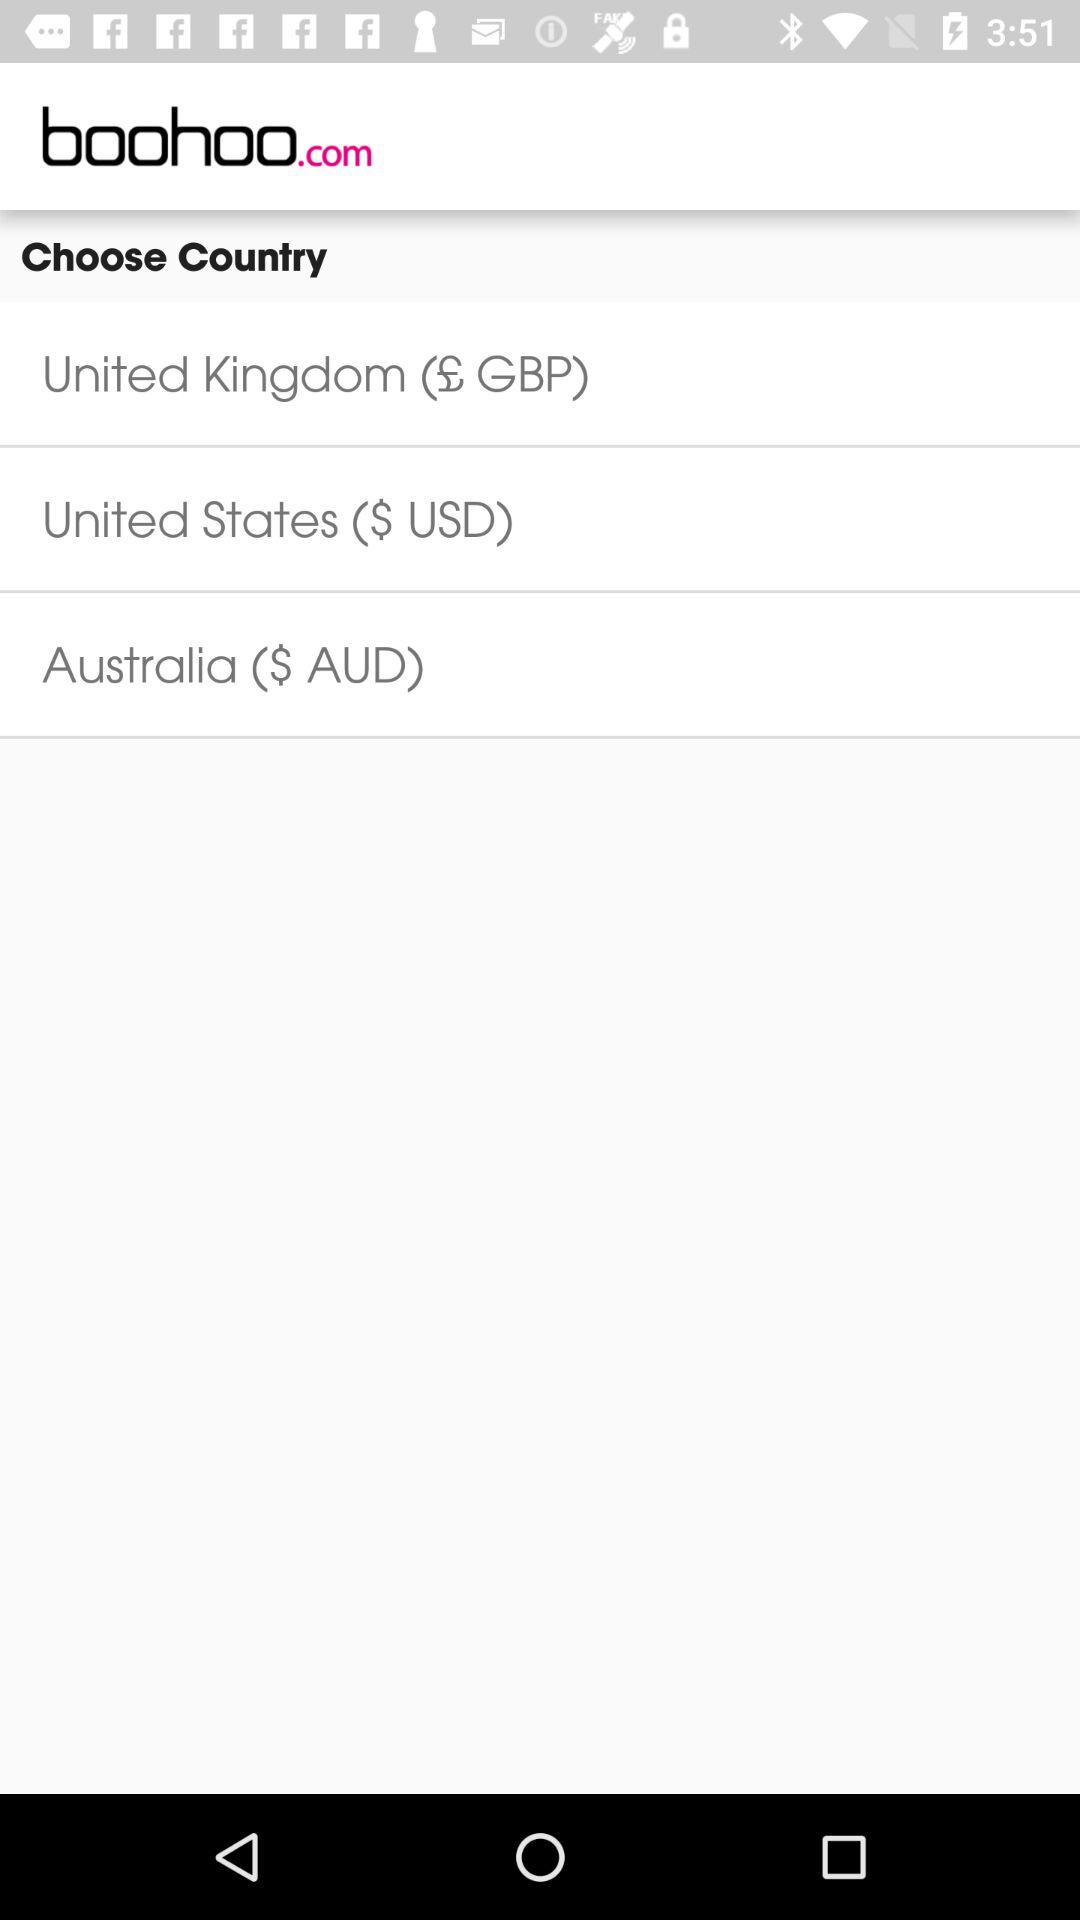What is the name of the application? The name of the application is "boohoo.com". 